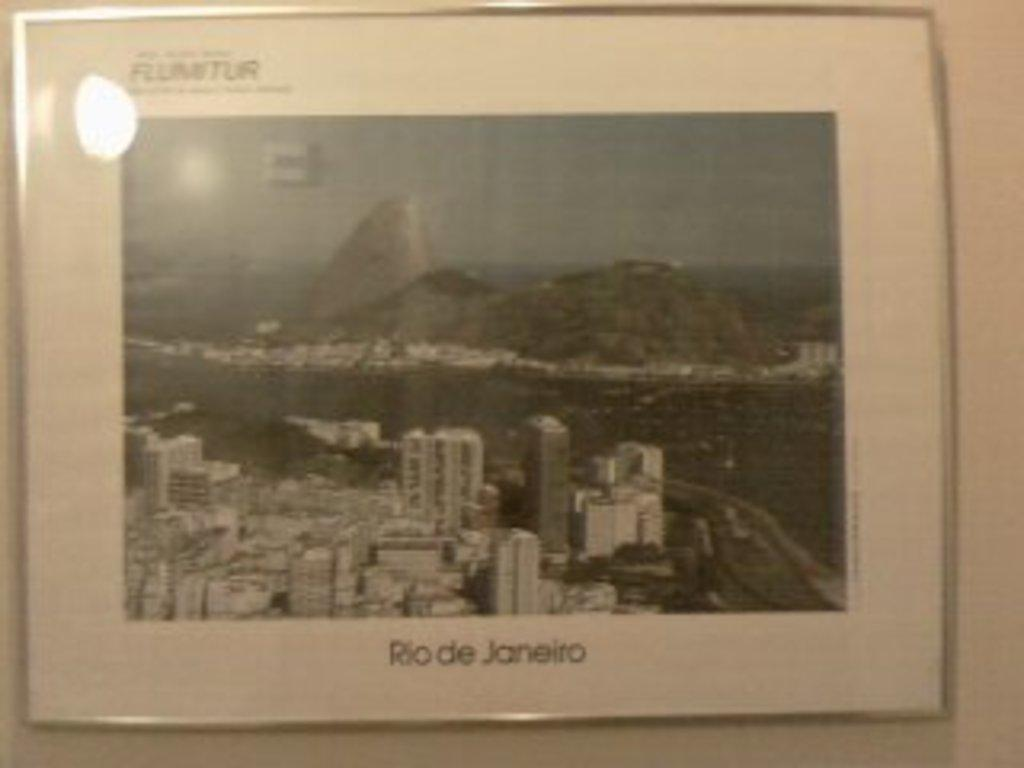What is hanging on the wall in the image? There is a frame on the wall in the image. What is inside the frame? The frame contains a picture. What is shown in the picture? The picture depicts buildings. What can be seen in the background of the picture? The sky is visible in the picture. Are there any words or letters in the picture? Yes, there is text in the picture. What type of net is being used to catch the copy in the image? There is no net or copy present in the image; it features a frame with a picture of buildings and text. 